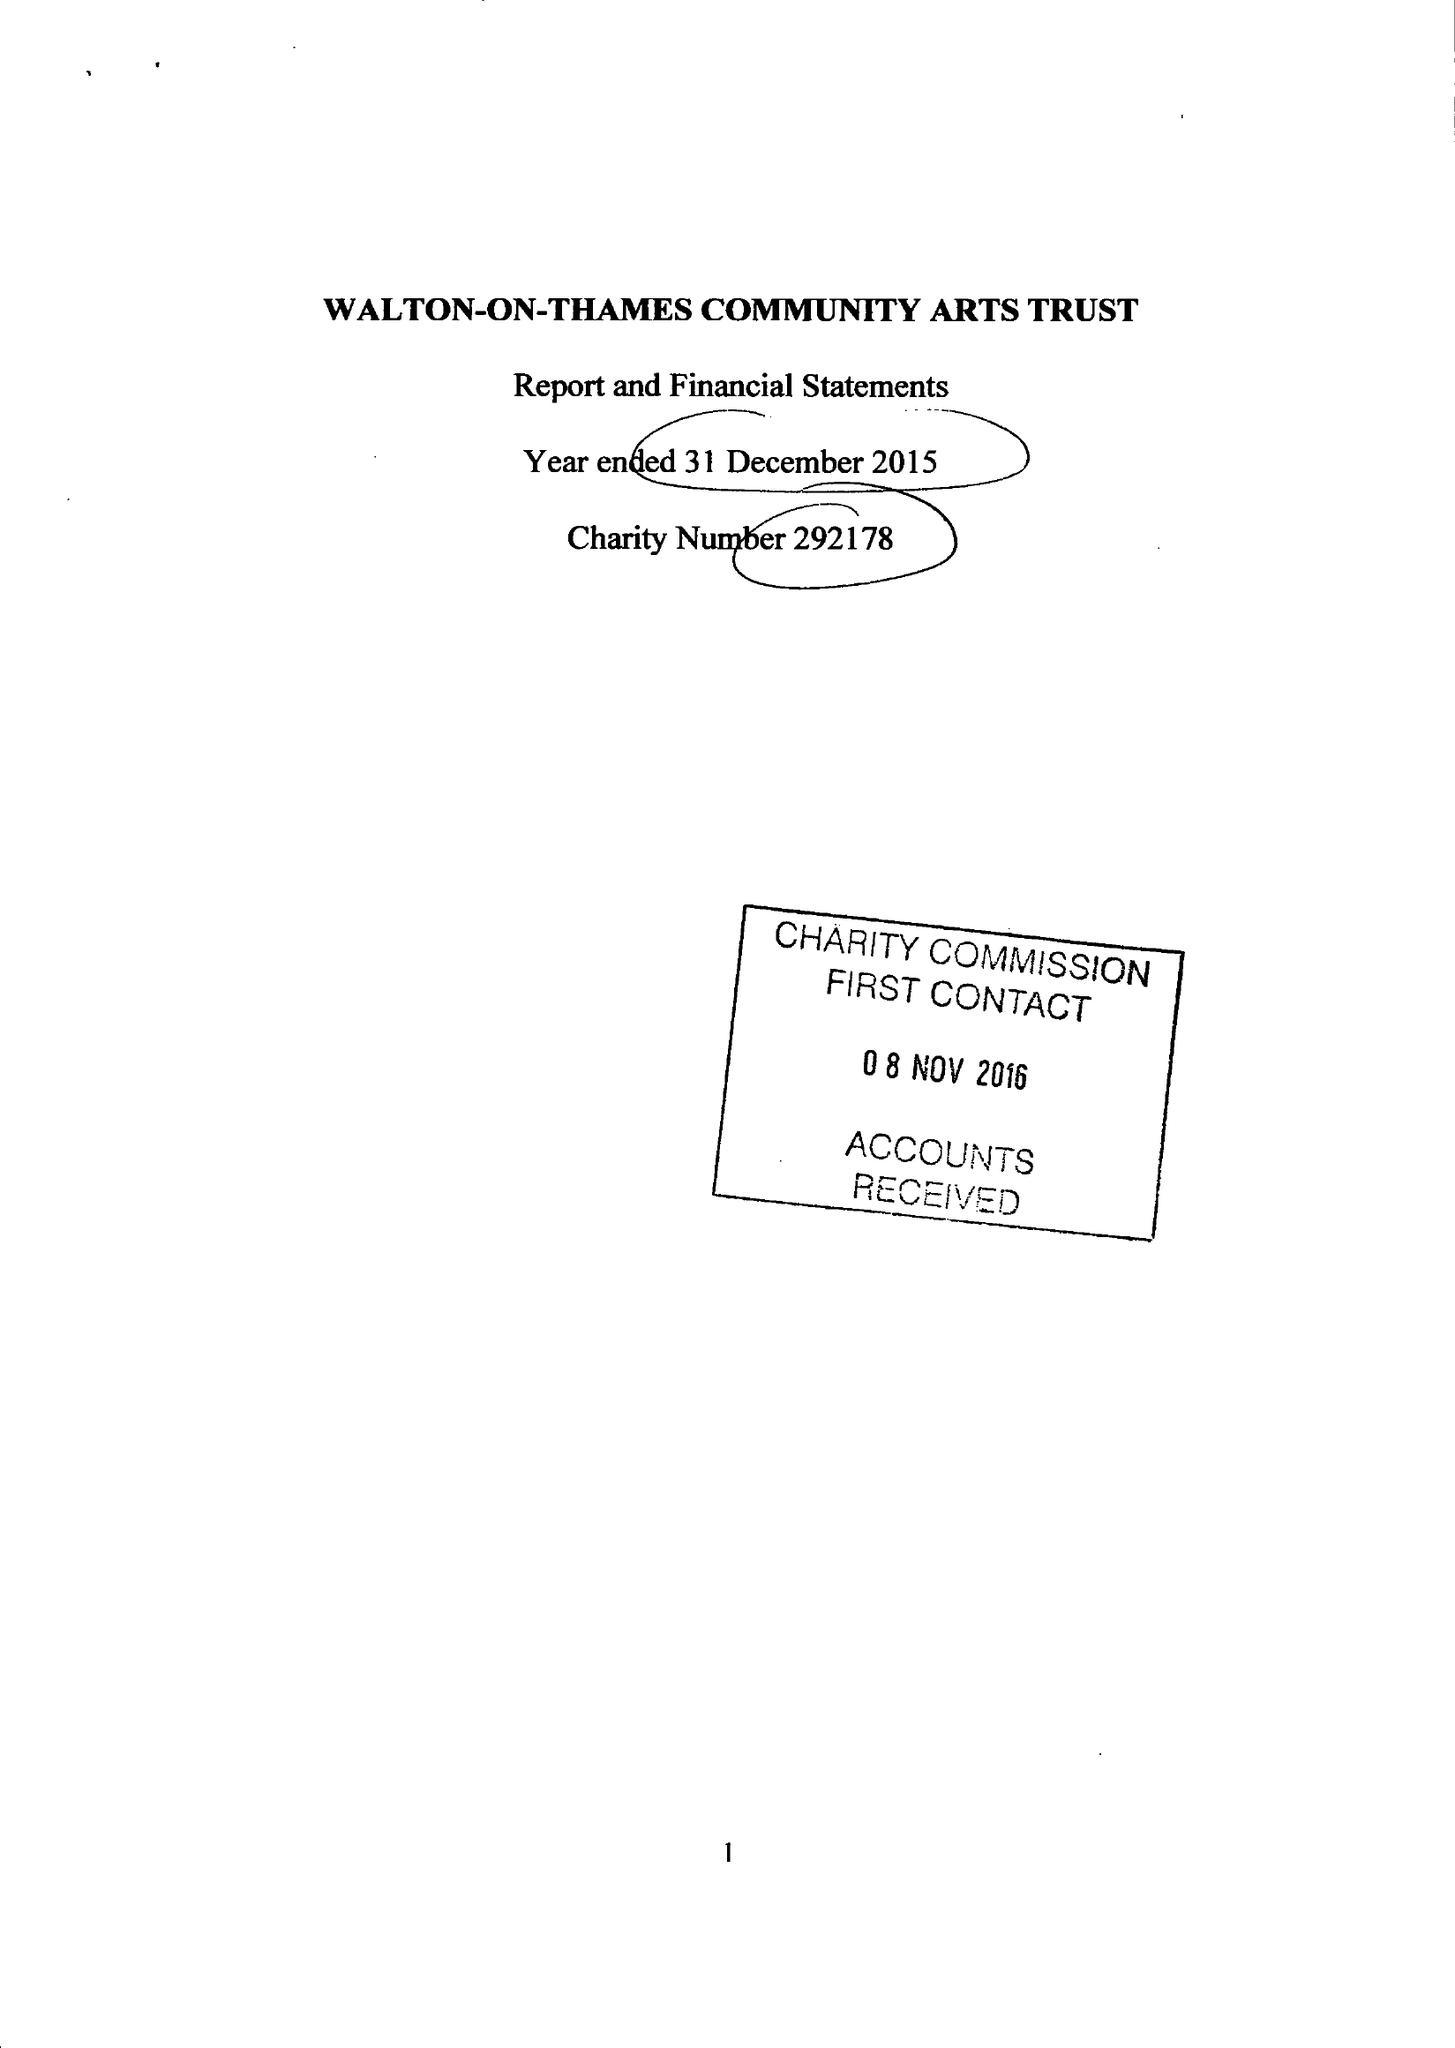What is the value for the report_date?
Answer the question using a single word or phrase. 2015-12-31 